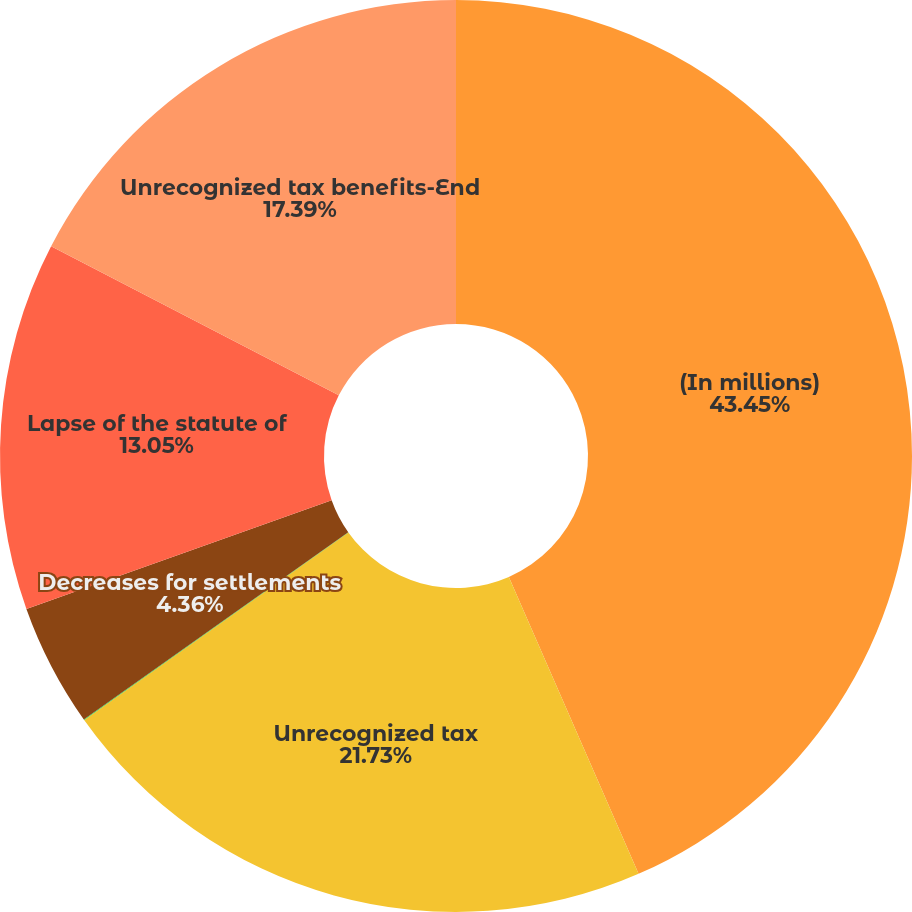<chart> <loc_0><loc_0><loc_500><loc_500><pie_chart><fcel>(In millions)<fcel>Unrecognized tax<fcel>Increases for tax positions<fcel>Decreases for settlements<fcel>Lapse of the statute of<fcel>Unrecognized tax benefits-End<nl><fcel>43.44%<fcel>21.73%<fcel>0.02%<fcel>4.36%<fcel>13.05%<fcel>17.39%<nl></chart> 